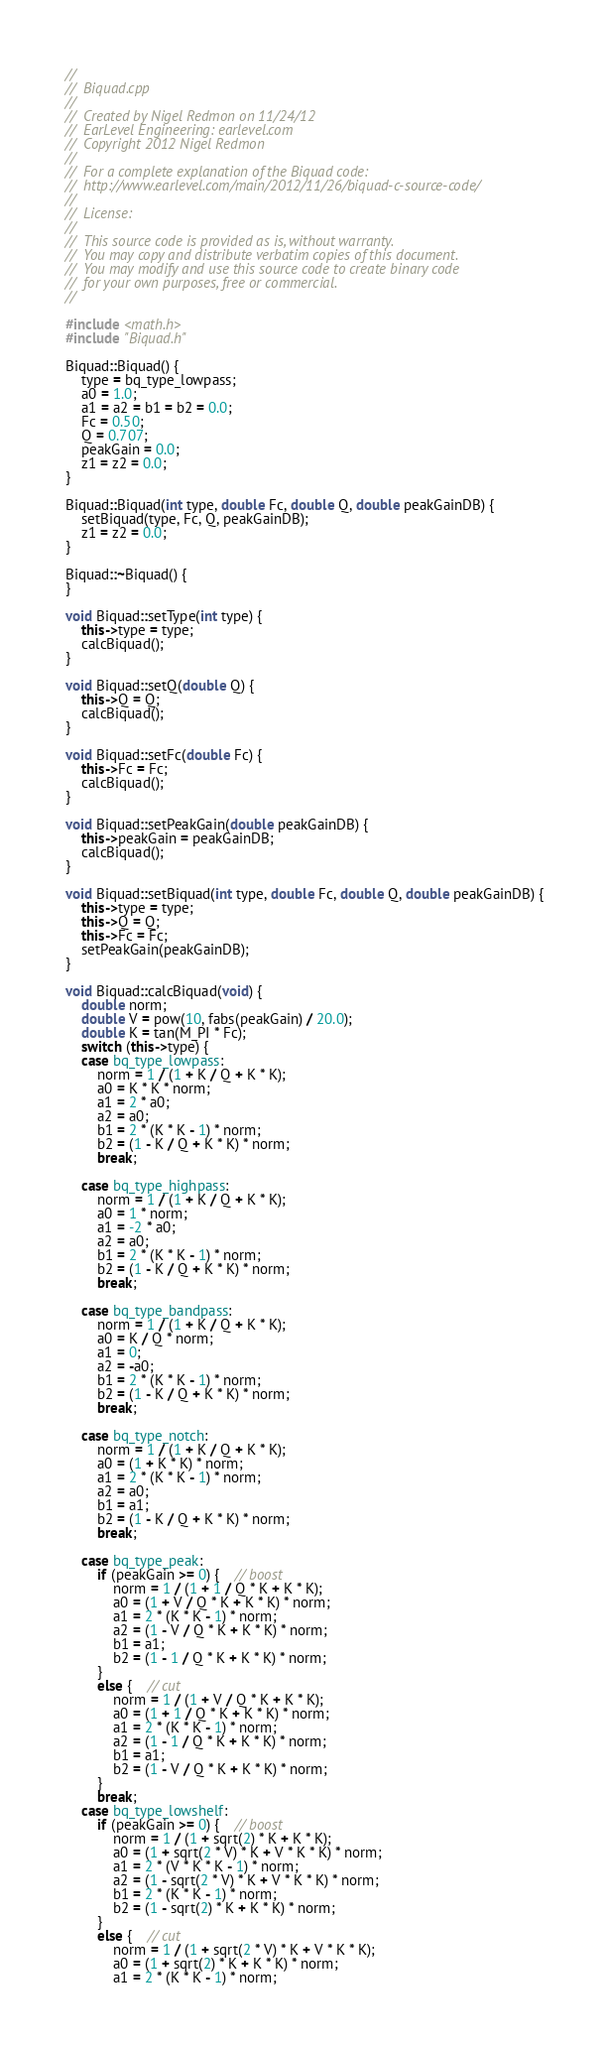<code> <loc_0><loc_0><loc_500><loc_500><_C++_>//
//  Biquad.cpp
//
//  Created by Nigel Redmon on 11/24/12
//  EarLevel Engineering: earlevel.com
//  Copyright 2012 Nigel Redmon
//
//  For a complete explanation of the Biquad code:
//  http://www.earlevel.com/main/2012/11/26/biquad-c-source-code/
//
//  License:
//
//  This source code is provided as is, without warranty.
//  You may copy and distribute verbatim copies of this document.
//  You may modify and use this source code to create binary code
//  for your own purposes, free or commercial.
//

#include <math.h>
#include "Biquad.h"

Biquad::Biquad() {
	type = bq_type_lowpass;
	a0 = 1.0;
	a1 = a2 = b1 = b2 = 0.0;
	Fc = 0.50;
	Q = 0.707;
	peakGain = 0.0;
	z1 = z2 = 0.0;
}

Biquad::Biquad(int type, double Fc, double Q, double peakGainDB) {
	setBiquad(type, Fc, Q, peakGainDB);
	z1 = z2 = 0.0;
}

Biquad::~Biquad() {
}

void Biquad::setType(int type) {
	this->type = type;
	calcBiquad();
}

void Biquad::setQ(double Q) {
	this->Q = Q;
	calcBiquad();
}

void Biquad::setFc(double Fc) {
	this->Fc = Fc;
	calcBiquad();
}

void Biquad::setPeakGain(double peakGainDB) {
	this->peakGain = peakGainDB;
	calcBiquad();
}

void Biquad::setBiquad(int type, double Fc, double Q, double peakGainDB) {
	this->type = type;
	this->Q = Q;
	this->Fc = Fc;
	setPeakGain(peakGainDB);
}

void Biquad::calcBiquad(void) {
	double norm;
	double V = pow(10, fabs(peakGain) / 20.0);
	double K = tan(M_PI * Fc);
	switch (this->type) {
	case bq_type_lowpass:
		norm = 1 / (1 + K / Q + K * K);
		a0 = K * K * norm;
		a1 = 2 * a0;
		a2 = a0;
		b1 = 2 * (K * K - 1) * norm;
		b2 = (1 - K / Q + K * K) * norm;
		break;

	case bq_type_highpass:
		norm = 1 / (1 + K / Q + K * K);
		a0 = 1 * norm;
		a1 = -2 * a0;
		a2 = a0;
		b1 = 2 * (K * K - 1) * norm;
		b2 = (1 - K / Q + K * K) * norm;
		break;

	case bq_type_bandpass:
		norm = 1 / (1 + K / Q + K * K);
		a0 = K / Q * norm;
		a1 = 0;
		a2 = -a0;
		b1 = 2 * (K * K - 1) * norm;
		b2 = (1 - K / Q + K * K) * norm;
		break;

	case bq_type_notch:
		norm = 1 / (1 + K / Q + K * K);
		a0 = (1 + K * K) * norm;
		a1 = 2 * (K * K - 1) * norm;
		a2 = a0;
		b1 = a1;
		b2 = (1 - K / Q + K * K) * norm;
		break;

	case bq_type_peak:
		if (peakGain >= 0) {    // boost
			norm = 1 / (1 + 1 / Q * K + K * K);
			a0 = (1 + V / Q * K + K * K) * norm;
			a1 = 2 * (K * K - 1) * norm;
			a2 = (1 - V / Q * K + K * K) * norm;
			b1 = a1;
			b2 = (1 - 1 / Q * K + K * K) * norm;
		}
		else {    // cut
			norm = 1 / (1 + V / Q * K + K * K);
			a0 = (1 + 1 / Q * K + K * K) * norm;
			a1 = 2 * (K * K - 1) * norm;
			a2 = (1 - 1 / Q * K + K * K) * norm;
			b1 = a1;
			b2 = (1 - V / Q * K + K * K) * norm;
		}
		break;
	case bq_type_lowshelf:
		if (peakGain >= 0) {    // boost
			norm = 1 / (1 + sqrt(2) * K + K * K);
			a0 = (1 + sqrt(2 * V) * K + V * K * K) * norm;
			a1 = 2 * (V * K * K - 1) * norm;
			a2 = (1 - sqrt(2 * V) * K + V * K * K) * norm;
			b1 = 2 * (K * K - 1) * norm;
			b2 = (1 - sqrt(2) * K + K * K) * norm;
		}
		else {    // cut
			norm = 1 / (1 + sqrt(2 * V) * K + V * K * K);
			a0 = (1 + sqrt(2) * K + K * K) * norm;
			a1 = 2 * (K * K - 1) * norm;</code> 